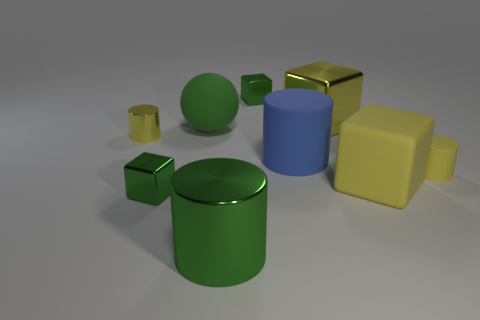How many blocks have the same color as the big rubber sphere?
Provide a succinct answer. 2. What number of things are small yellow shiny objects or small green objects?
Your response must be concise. 3. The tiny thing on the right side of the tiny green shiny thing that is behind the tiny matte thing is made of what material?
Your answer should be very brief. Rubber. Is there a tiny green cube that has the same material as the green cylinder?
Offer a terse response. Yes. The large green thing that is behind the large metal object that is in front of the yellow thing behind the small yellow metallic object is what shape?
Keep it short and to the point. Sphere. What is the material of the green cylinder?
Keep it short and to the point. Metal. What is the color of the large cube that is made of the same material as the green cylinder?
Provide a short and direct response. Yellow. There is a tiny green metal block in front of the big matte cube; are there any tiny metal cylinders in front of it?
Offer a very short reply. No. What number of other things are there of the same shape as the blue rubber thing?
Give a very brief answer. 3. There is a tiny yellow object right of the blue cylinder; is it the same shape as the big shiny object in front of the yellow rubber cylinder?
Offer a very short reply. Yes. 